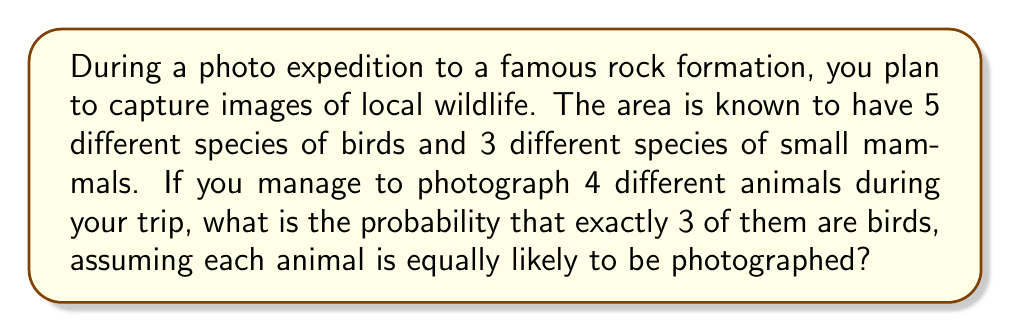Can you answer this question? Let's approach this step-by-step using combinatorics:

1) First, we need to calculate the total number of ways to choose 4 animals out of the 8 total species:
   $$\binom{8}{4} = \frac{8!}{4!(8-4)!} = \frac{8!}{4!4!} = 70$$

2) Now, we need to calculate the number of ways to choose 3 birds out of 5 and 1 mammal out of 3:
   $$\binom{5}{3} \cdot \binom{3}{1} = \frac{5!}{3!2!} \cdot \frac{3!}{1!2!} = 10 \cdot 3 = 30$$

3) The probability is then the number of favorable outcomes divided by the total number of possible outcomes:

   $$P(\text{3 birds and 1 mammal}) = \frac{\text{Number of ways to choose 3 birds and 1 mammal}}{\text{Total number of ways to choose 4 animals}}$$

   $$P(\text{3 birds and 1 mammal}) = \frac{30}{70} = \frac{3}{7}$$
Answer: $\frac{3}{7}$ 